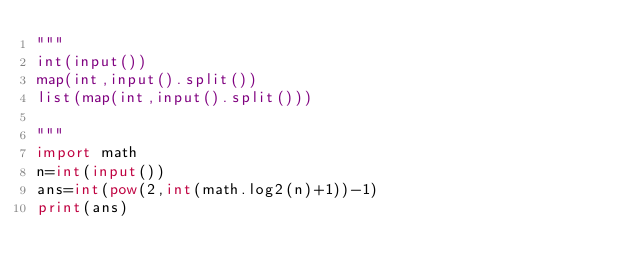<code> <loc_0><loc_0><loc_500><loc_500><_Python_>"""
int(input())
map(int,input().split())
list(map(int,input().split()))

"""
import math
n=int(input())
ans=int(pow(2,int(math.log2(n)+1))-1)
print(ans)</code> 